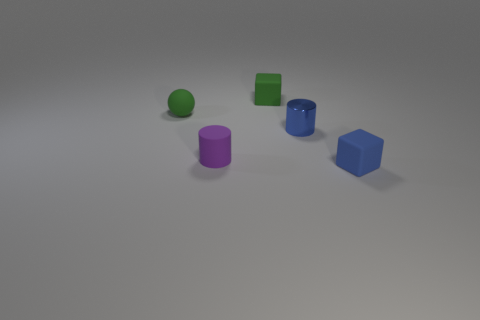Add 3 small metallic cylinders. How many objects exist? 8 Subtract all cylinders. How many objects are left? 3 Subtract all green rubber objects. Subtract all blue cylinders. How many objects are left? 2 Add 4 tiny purple objects. How many tiny purple objects are left? 5 Add 5 tiny brown things. How many tiny brown things exist? 5 Subtract 0 brown blocks. How many objects are left? 5 Subtract all gray cylinders. Subtract all brown blocks. How many cylinders are left? 2 